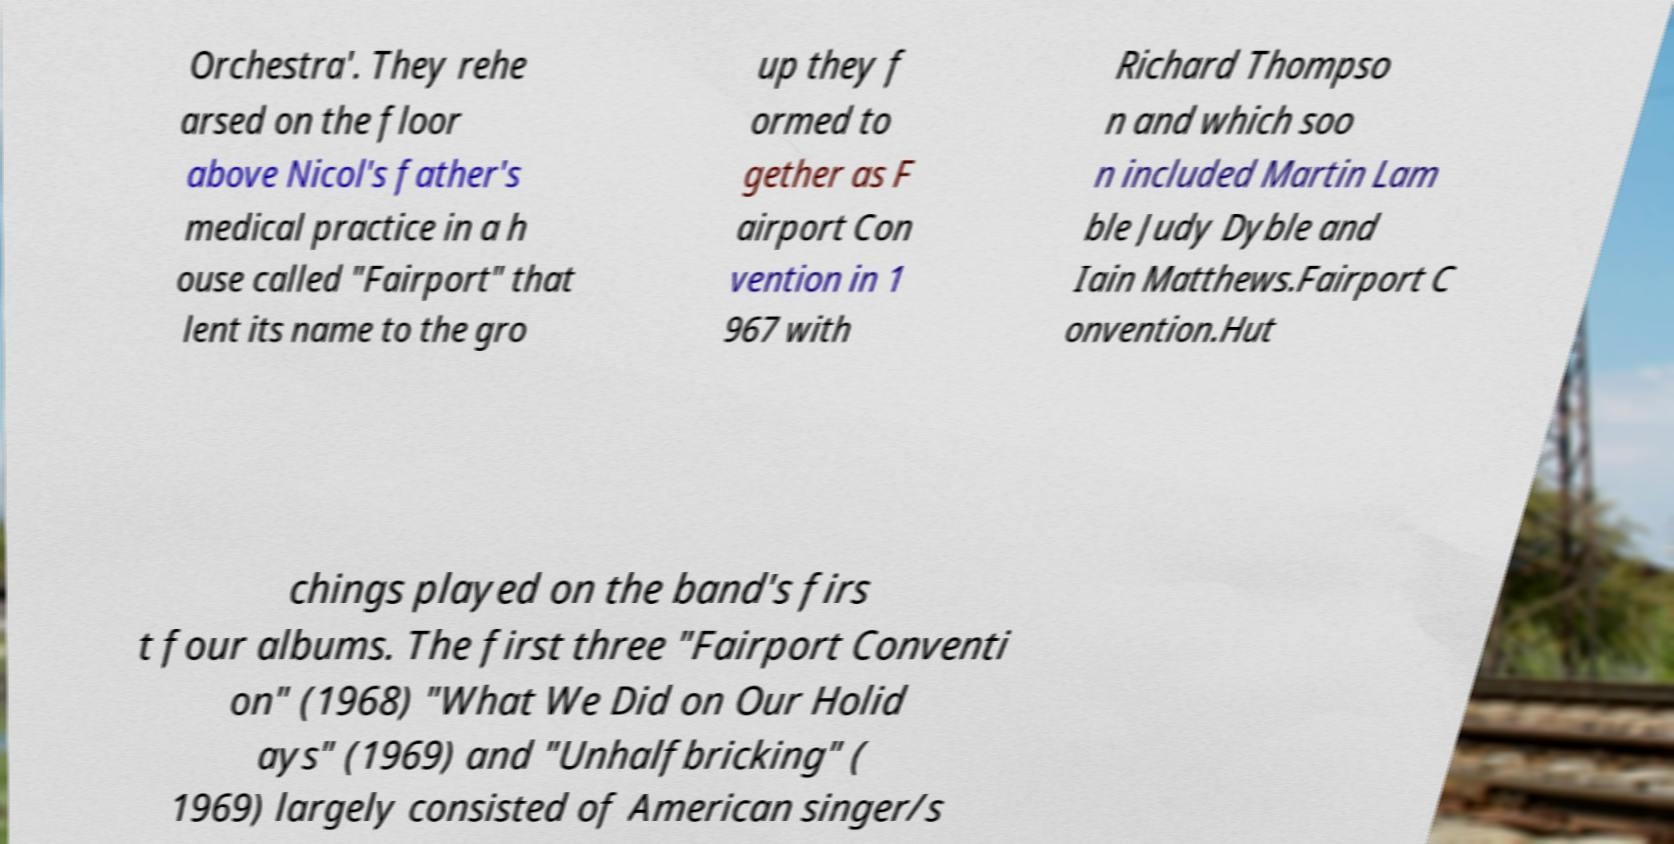What messages or text are displayed in this image? I need them in a readable, typed format. Orchestra'. They rehe arsed on the floor above Nicol's father's medical practice in a h ouse called "Fairport" that lent its name to the gro up they f ormed to gether as F airport Con vention in 1 967 with Richard Thompso n and which soo n included Martin Lam ble Judy Dyble and Iain Matthews.Fairport C onvention.Hut chings played on the band's firs t four albums. The first three "Fairport Conventi on" (1968) "What We Did on Our Holid ays" (1969) and "Unhalfbricking" ( 1969) largely consisted of American singer/s 